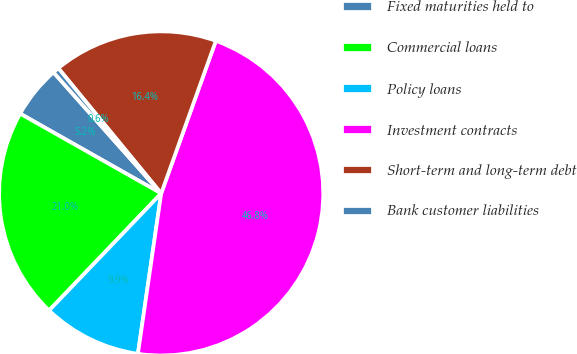<chart> <loc_0><loc_0><loc_500><loc_500><pie_chart><fcel>Fixed maturities held to<fcel>Commercial loans<fcel>Policy loans<fcel>Investment contracts<fcel>Short-term and long-term debt<fcel>Bank customer liabilities<nl><fcel>5.24%<fcel>21.04%<fcel>9.86%<fcel>46.82%<fcel>16.42%<fcel>0.62%<nl></chart> 